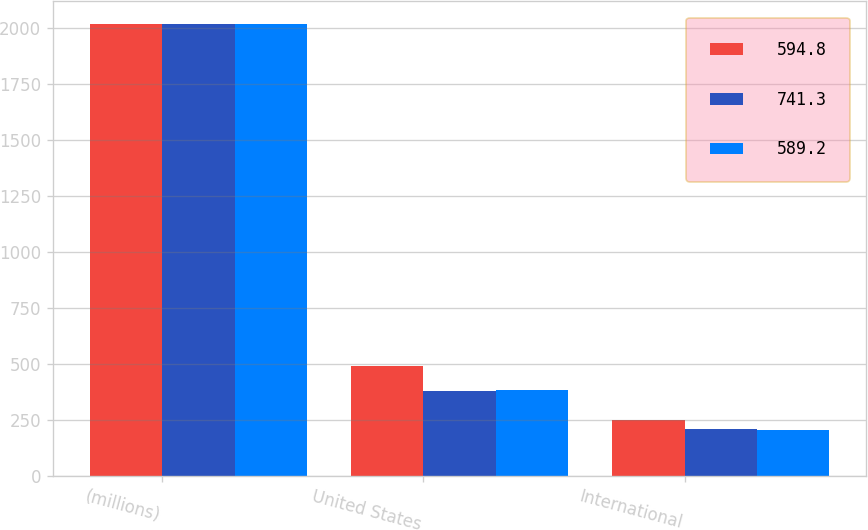<chart> <loc_0><loc_0><loc_500><loc_500><stacked_bar_chart><ecel><fcel>(millions)<fcel>United States<fcel>International<nl><fcel>594.8<fcel>2018<fcel>492.2<fcel>249.1<nl><fcel>741.3<fcel>2017<fcel>382.1<fcel>212.7<nl><fcel>589.2<fcel>2016<fcel>383.3<fcel>205.9<nl></chart> 